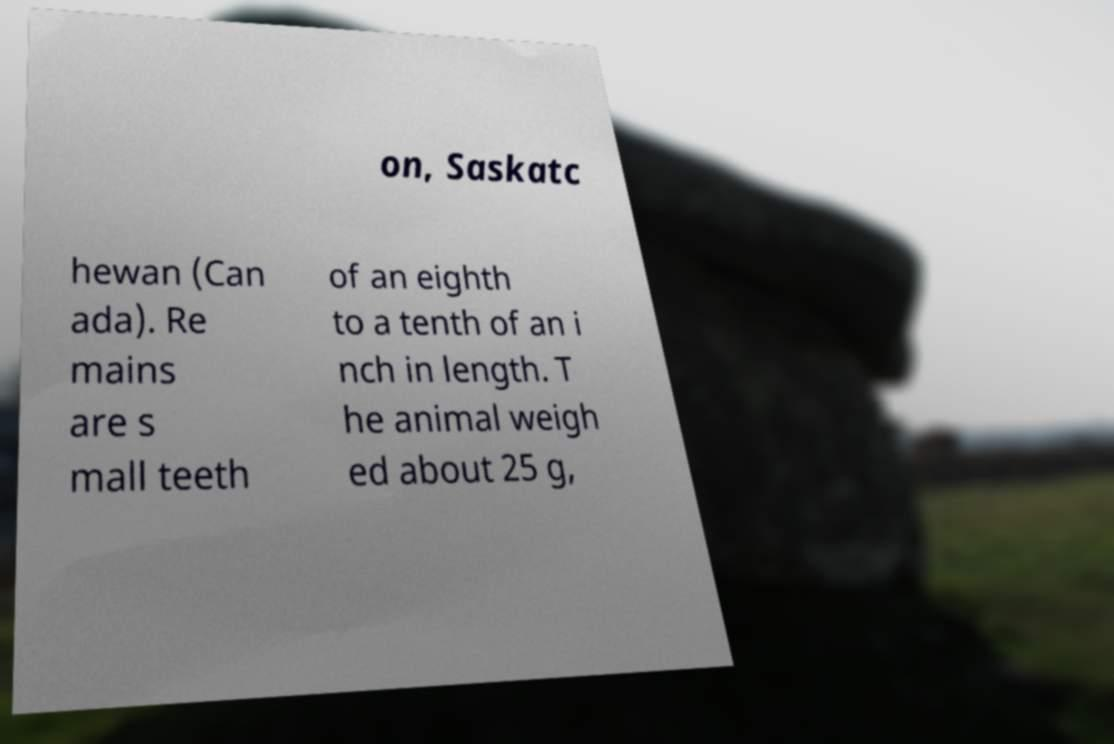Can you read and provide the text displayed in the image?This photo seems to have some interesting text. Can you extract and type it out for me? on, Saskatc hewan (Can ada). Re mains are s mall teeth of an eighth to a tenth of an i nch in length. T he animal weigh ed about 25 g, 